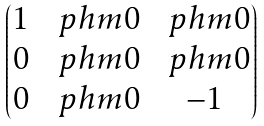<formula> <loc_0><loc_0><loc_500><loc_500>\begin{pmatrix} 1 & \, \ p h m 0 & \, \ p h m 0 \\ 0 & \, \ p h m 0 & \, \ p h m 0 \\ 0 & \, \ p h m 0 & \, - 1 \end{pmatrix}</formula> 